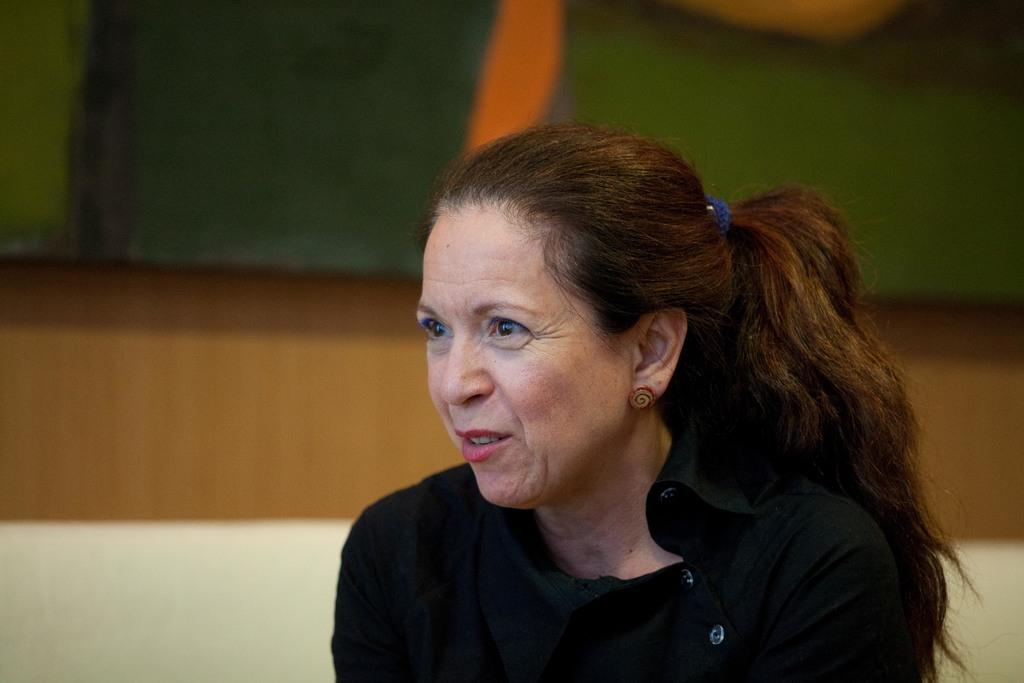Who is the main subject in the image? There is a woman in the image. What is the woman wearing? The woman is wearing black clothes. Can you describe the background of the image? The background of the image is blurred. What type of eggnog is the woman holding in the image? There is no eggnog present in the image; the woman is not holding anything. How many kittens are sitting on the coach in the image? There is no coach or kittens present in the image. 